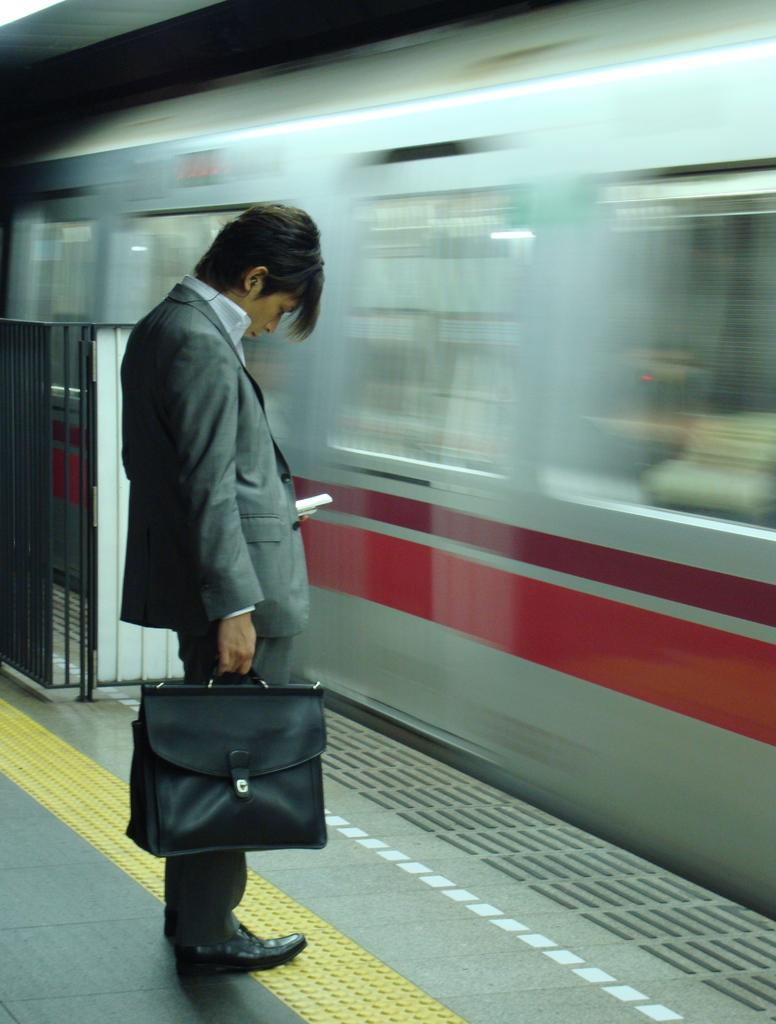What can be seen in the image? There is a person in the image. What is the person holding? The person is holding an object. What type of surface is visible in the image? There is ground visible in the image. What material is the metal object made of? The metal object in the image is made of metal. What mode of transportation is present in the image? There is a train in the image. How many frogs are sitting on the train in the image? There are no frogs present in the image, so it is not possible to determine the number of frogs on the train. 